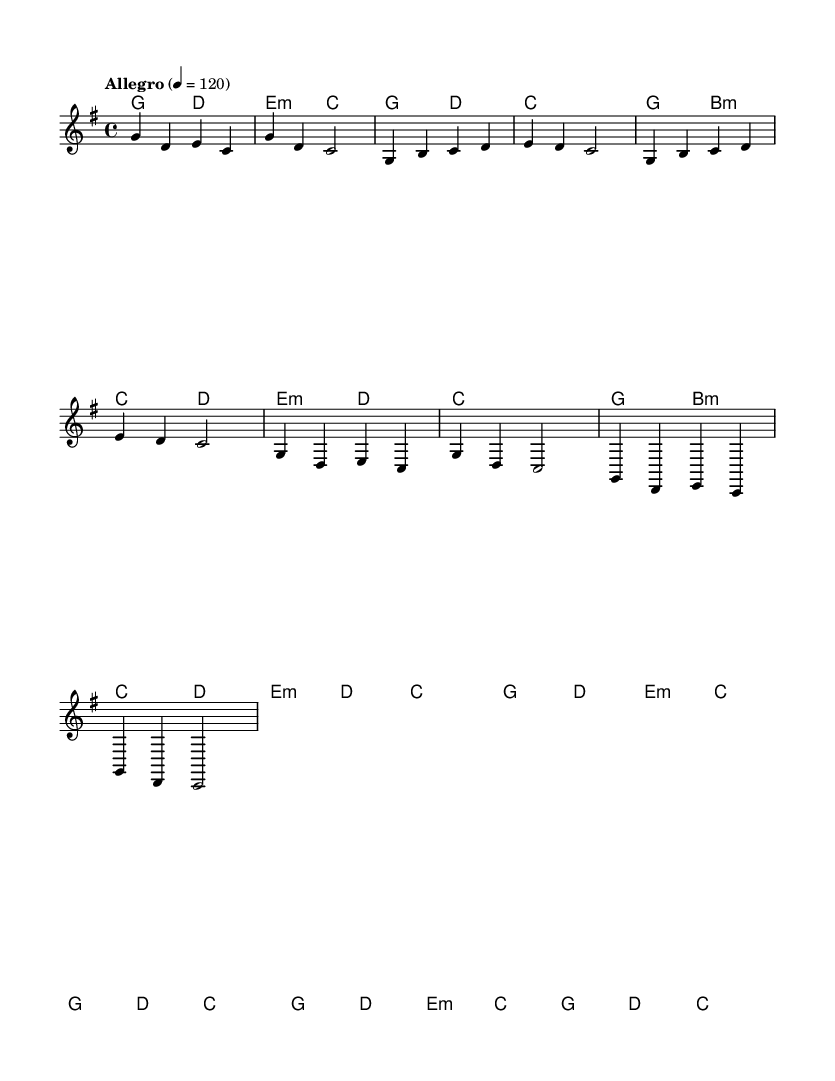What is the key signature of this music? The key signature is G major, indicated by one sharp (F#), which is shown in the beginning of the staff.
Answer: G major What is the time signature of this music? The time signature is 4/4, which is indicated at the beginning of the score and means there are four beats in a measure.
Answer: 4/4 What is the tempo marking of this piece? The tempo marking is "Allegro," which indicates a brisk and lively pace, and the beats per minute are specified as 120.
Answer: Allegro What is the number of measures in the verse section? The verse consists of 8 measures, which can be counted by identifying the distinct groupings in the score and measuring lines.
Answer: 8 How many different chords are used in the harmonic progression? The harmonic progression contains 5 different chords: G, D, E minor, C, and B minor, as seen in the chord names throughout the piece.
Answer: 5 What is the main theme of the lyrics in the chorus? The main theme of the lyrics in the chorus revolves around streaming, gaming legends, and the influence of the stream team, which can be interpreted from the lyrical content.
Answer: Streaming influence How many times does the chorus appear in the music? The chorus appears 2 times, as indicated by the repetition of the chorus lyrics following the verse sections.
Answer: 2 